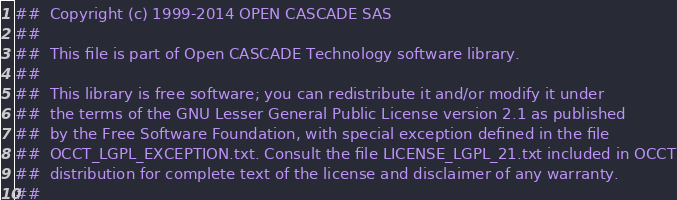Convert code to text. <code><loc_0><loc_0><loc_500><loc_500><_Nim_>##  Copyright (c) 1999-2014 OPEN CASCADE SAS
##
##  This file is part of Open CASCADE Technology software library.
##
##  This library is free software; you can redistribute it and/or modify it under
##  the terms of the GNU Lesser General Public License version 2.1 as published
##  by the Free Software Foundation, with special exception defined in the file
##  OCCT_LGPL_EXCEPTION.txt. Consult the file LICENSE_LGPL_21.txt included in OCCT
##  distribution for complete text of the license and disclaimer of any warranty.
##</code> 